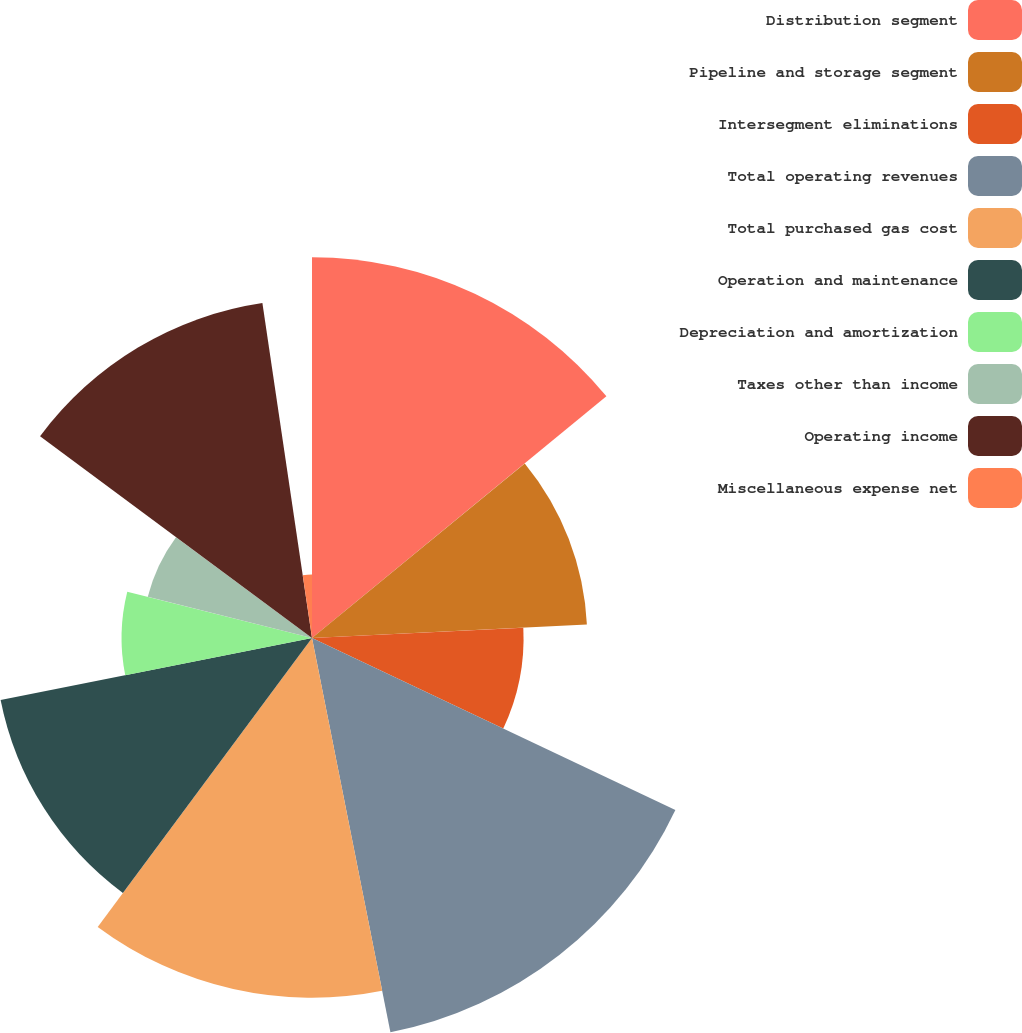Convert chart to OTSL. <chart><loc_0><loc_0><loc_500><loc_500><pie_chart><fcel>Distribution segment<fcel>Pipeline and storage segment<fcel>Intersegment eliminations<fcel>Total operating revenues<fcel>Total purchased gas cost<fcel>Operation and maintenance<fcel>Depreciation and amortization<fcel>Taxes other than income<fcel>Operating income<fcel>Miscellaneous expense net<nl><fcel>14.06%<fcel>10.16%<fcel>7.81%<fcel>14.84%<fcel>13.28%<fcel>11.72%<fcel>7.03%<fcel>6.25%<fcel>12.5%<fcel>2.34%<nl></chart> 